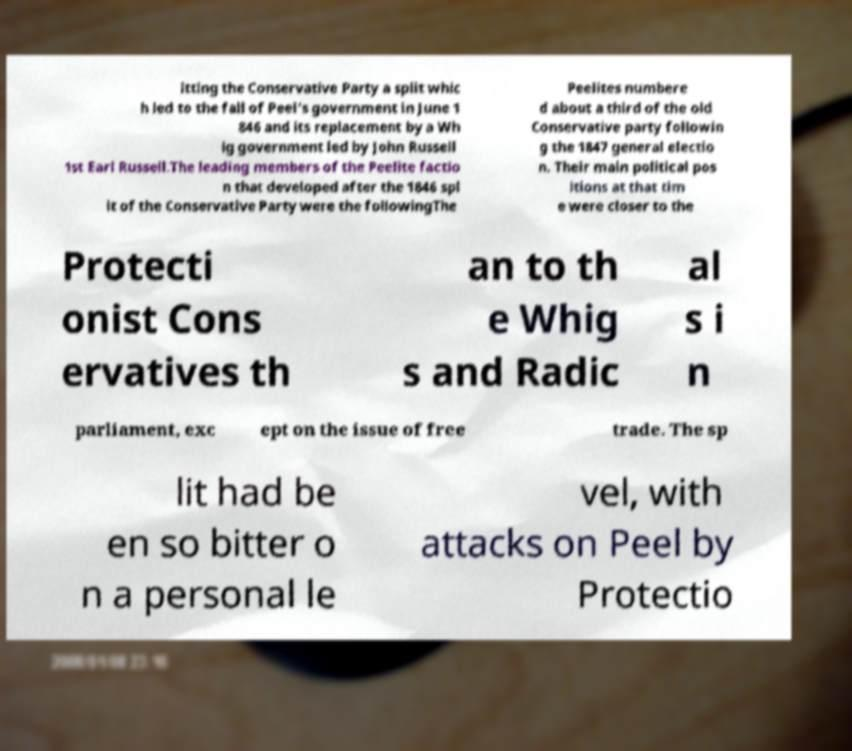I need the written content from this picture converted into text. Can you do that? itting the Conservative Party a split whic h led to the fall of Peel's government in June 1 846 and its replacement by a Wh ig government led by John Russell 1st Earl Russell.The leading members of the Peelite factio n that developed after the 1846 spl it of the Conservative Party were the followingThe Peelites numbere d about a third of the old Conservative party followin g the 1847 general electio n. Their main political pos itions at that tim e were closer to the Protecti onist Cons ervatives th an to th e Whig s and Radic al s i n parliament, exc ept on the issue of free trade. The sp lit had be en so bitter o n a personal le vel, with attacks on Peel by Protectio 